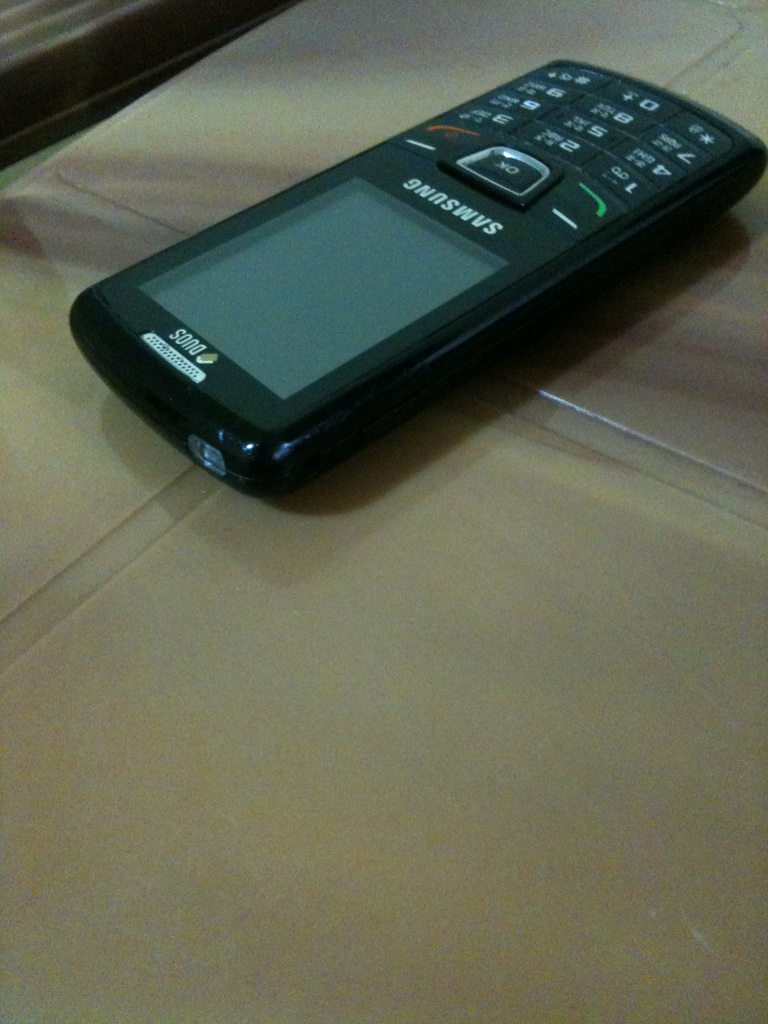What is this? What is this? from Vizwiz The image shows a feature phone, specifically a Samsung model, which differs from smartphones in that it has physical buttons and a smaller screen, and typically provides basic call and text functionalities. 